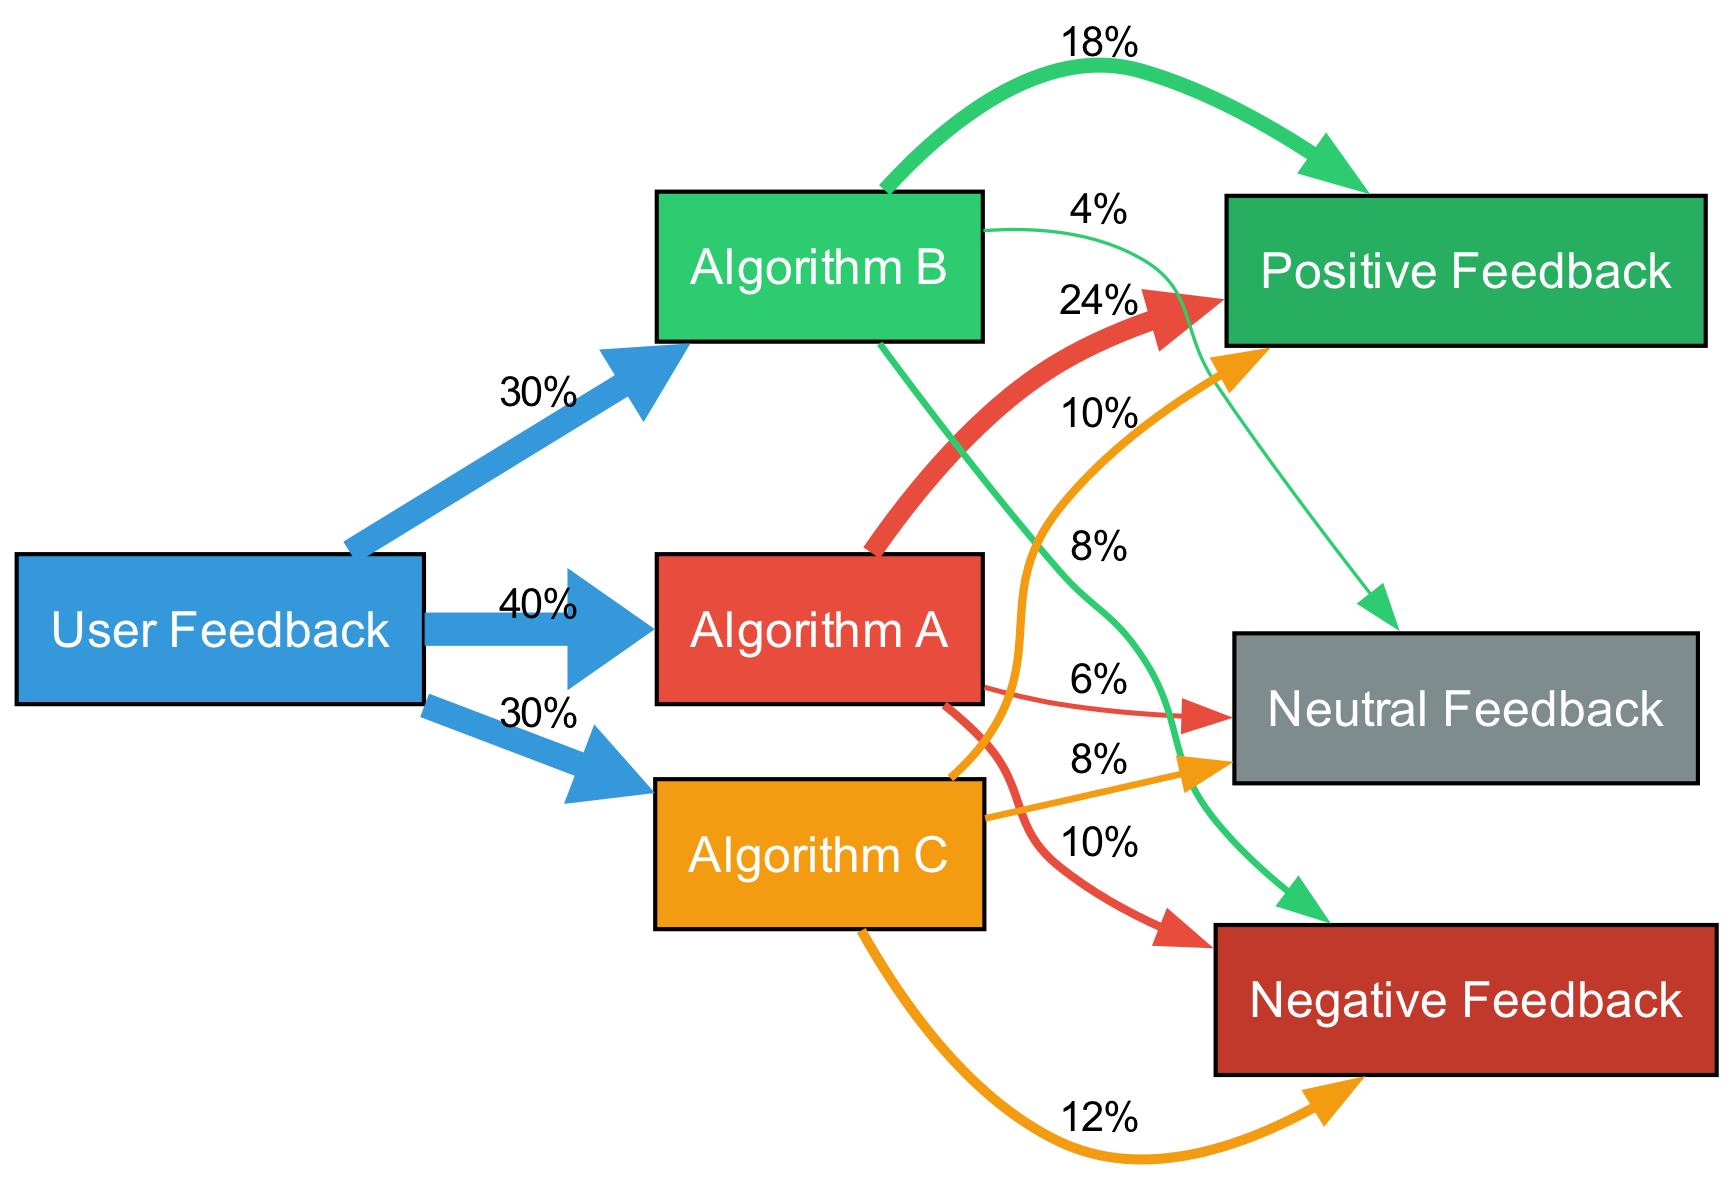What percentage of users provided feedback on Algorithm A? The diagram shows a link from "User Feedback" to "Algorithm A" with a value of 40%. This indicates that 40% of the total user feedback pertains specifically to Algorithm A.
Answer: 40% Which algorithm received the highest positive feedback? The connections from each algorithm are examined. Algorithm A has 24% positive feedback, Algorithm B has 18%, and Algorithm C has 10%. The highest of these values is 24%.
Answer: Algorithm A What is the total percentage of negative feedback across all algorithms? Looking at the negative feedback values for each algorithm: Algorithm A has 10%, Algorithm B has 8%, and Algorithm C has 12%. Summing these gives 10% + 8% + 12% = 30%.
Answer: 30% How many nodes are there in the diagram? By counting each distinct node in the diagram, we see there are 7 nodes: User Feedback, Algorithm A, Algorithm B, Algorithm C, Positive Feedback, Negative Feedback, and Neutral Feedback.
Answer: 7 What percentage of feedback is neutral for Algorithm B? The link from Algorithm B to Neutral Feedback indicates a value of 4%. This represents the percentage of users who felt neutral regarding Algorithm B's bias mitigation effectiveness.
Answer: 4% Which algorithm has the least total user feedback? The distribution of user feedback shows 40% for Algorithm A, 30% for Algorithm B, and 30% for Algorithm C. Algorithms B and C tie for the least total user feedback with 30%.
Answer: Algorithm B and Algorithm C How much more positive feedback did Algorithm A receive compared to Algorithm C? Algorithm A has 24% positive feedback, and Algorithm C has 10%. The difference is calculated by subtracting the two: 24% - 10% = 14%.
Answer: 14% What percentage of users felt negatively about Algorithm C? The link from Algorithm C to Negative Feedback shows a value of 12%, indicating the percentage of users who expressed dissatisfaction with this algorithm.
Answer: 12% Which feedback type is most associated with Algorithm C? Reviewing the connections from Algorithm C, the values are: Positive 10%, Negative 12%, and Neutral 8%. The highest value is for Negative Feedback at 12%.
Answer: Negative Feedback 